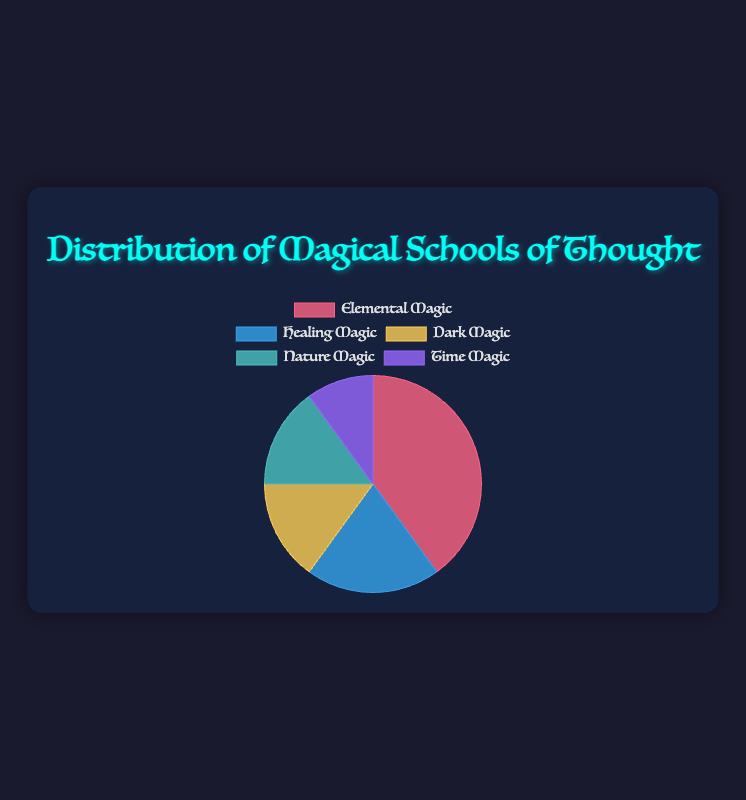What is the most prevalent magical school of thought in the pie chart? The Elemental Magic section of the pie chart has the largest percentage at 40%.
Answer: Elemental Magic Which magical schools of thought have the same percentage of representation, and what is that percentage? Both Dark Magic and Nature Magic have equal representation at 15%.
Answer: Dark Magic and Nature Magic, 15% How much more prevalent is Elemental Magic compared to Healing Magic? Elemental Magic is depicted at 40% while Healing Magic at 20%. Subtracting the two values: 40% - 20% results in 20%.
Answer: 20% What is the combined percentage representation of Dark Magic and Nature Magic? Dark Magic has 15% and Nature Magic also has 15%. Adding these together: 15% + 15% results in 30%.
Answer: 30% Which category is represented by the smallest section of the pie chart, and what color is it represented in? The smallest section of the pie chart is Time Magic at 10%, represented by the purple color.
Answer: Time Magic, purple What is the total percentage of the two least prevalent magical schools of thought? The least prevalent magical schools of thought are Time Magic (10%) and both Dark Magic and Nature Magic (both at 15% each), thereby making Dark Magic and Nature Magic combined as 30% which does not fit the requirement. Thus, summing Healing Magic (20%) and Time Magic (10%) instead: 20% + 10% equals 30%.
Answer: 30% Arrange the magical schools of thought by their percentage representations in descending order. The percentages in descending order are: Elemental Magic (40%), Healing Magic (20%), Dark Magic (15%) = Nature Magic (15%), Time Magic (10%).
Answer: Elemental, Healing, Dark = Nature, Time What are the primary colors used in the pie chart to represent the different magical schools of thought? The primary colors used are red for Elemental Magic, blue for Healing Magic, yellow for Dark Magic, green for Nature Magic, and purple for Time Magic.
Answer: Red, blue, yellow, green, purple 